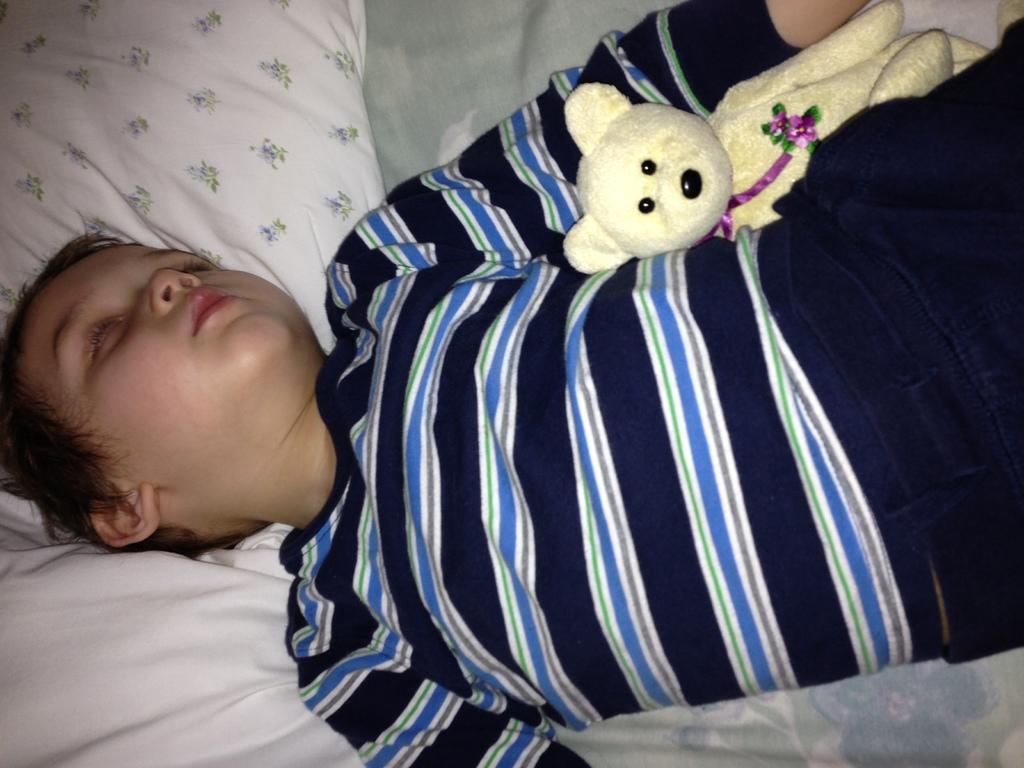Can you describe this image briefly? In this image we can see a boy is sleeping. He is wearing black and blue color t-shirt and beside him one teddy bear is there. Under his head white color pillow is present. 